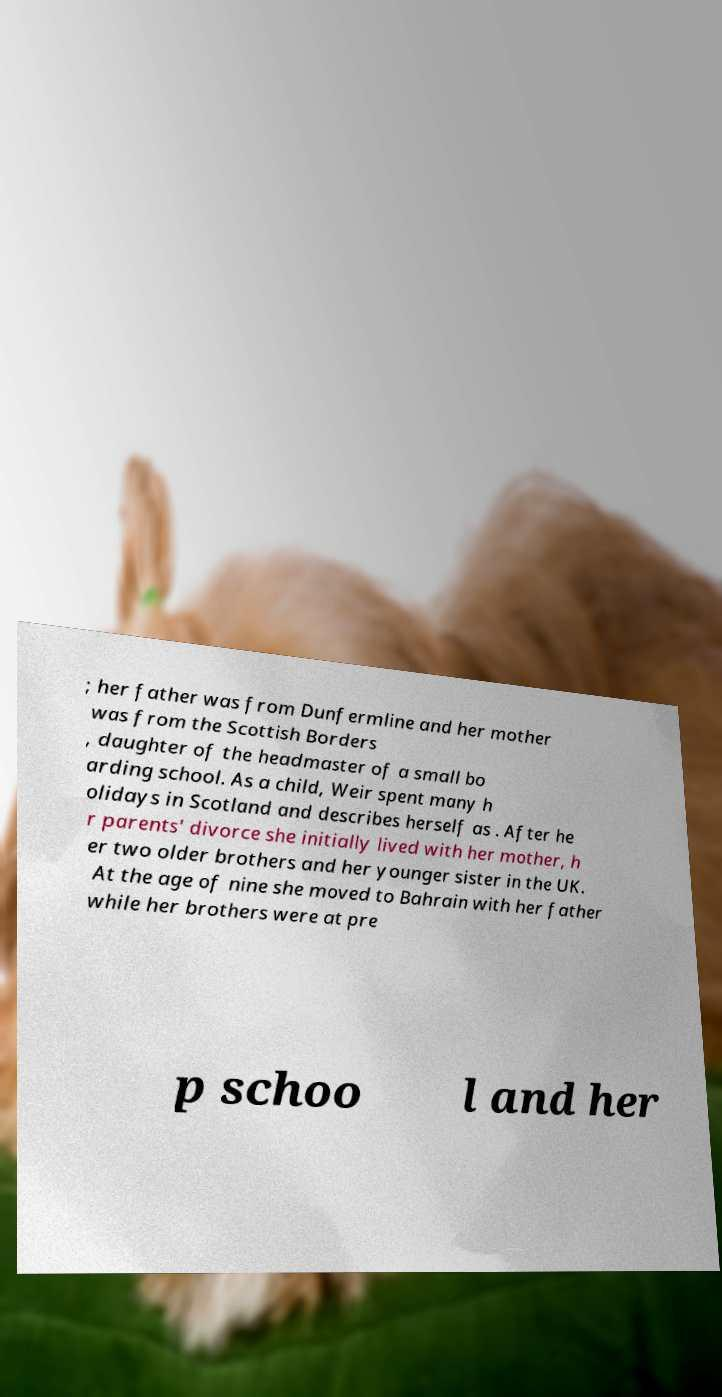Please identify and transcribe the text found in this image. ; her father was from Dunfermline and her mother was from the Scottish Borders , daughter of the headmaster of a small bo arding school. As a child, Weir spent many h olidays in Scotland and describes herself as . After he r parents' divorce she initially lived with her mother, h er two older brothers and her younger sister in the UK. At the age of nine she moved to Bahrain with her father while her brothers were at pre p schoo l and her 